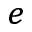<formula> <loc_0><loc_0><loc_500><loc_500>^ { e }</formula> 